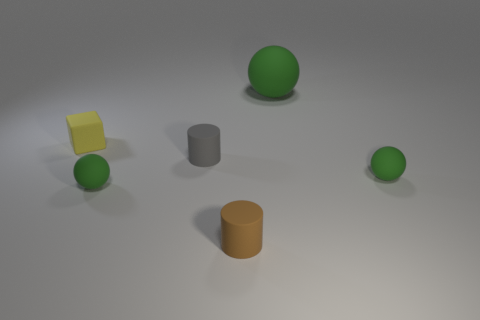Add 4 small yellow metallic cylinders. How many objects exist? 10 Subtract all cylinders. How many objects are left? 4 Subtract all small red balls. Subtract all tiny gray objects. How many objects are left? 5 Add 3 balls. How many balls are left? 6 Add 6 purple metal cylinders. How many purple metal cylinders exist? 6 Subtract 1 brown cylinders. How many objects are left? 5 